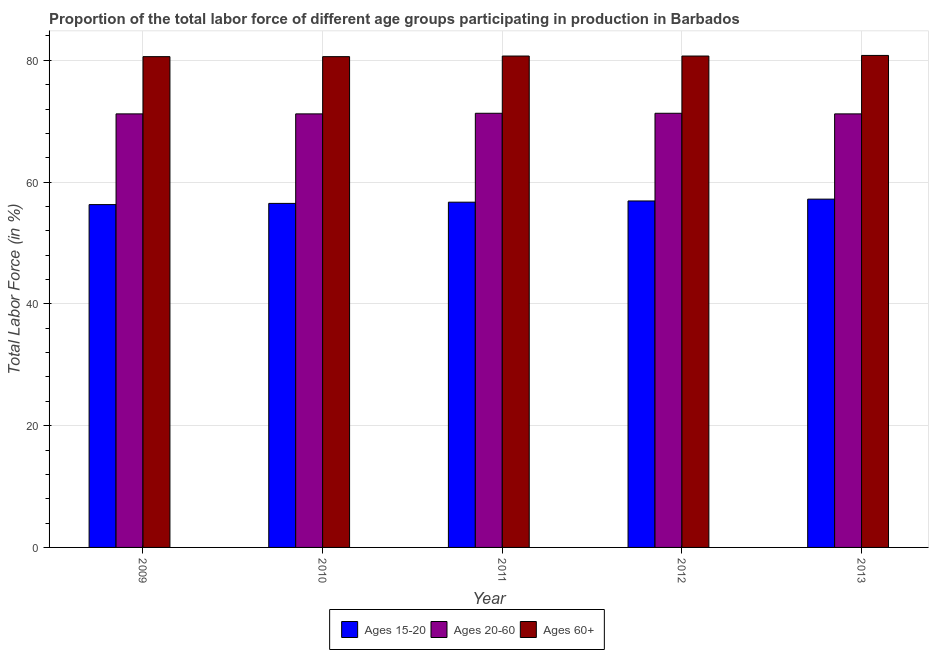How many bars are there on the 5th tick from the left?
Your answer should be compact. 3. How many bars are there on the 5th tick from the right?
Keep it short and to the point. 3. What is the label of the 4th group of bars from the left?
Offer a terse response. 2012. What is the percentage of labor force within the age group 20-60 in 2011?
Make the answer very short. 71.3. Across all years, what is the maximum percentage of labor force within the age group 15-20?
Provide a succinct answer. 57.2. Across all years, what is the minimum percentage of labor force within the age group 15-20?
Make the answer very short. 56.3. In which year was the percentage of labor force above age 60 maximum?
Provide a succinct answer. 2013. What is the total percentage of labor force within the age group 15-20 in the graph?
Give a very brief answer. 283.6. What is the difference between the percentage of labor force within the age group 20-60 in 2010 and that in 2011?
Make the answer very short. -0.1. What is the difference between the percentage of labor force within the age group 20-60 in 2013 and the percentage of labor force within the age group 15-20 in 2012?
Give a very brief answer. -0.1. What is the average percentage of labor force within the age group 15-20 per year?
Your answer should be very brief. 56.72. In the year 2009, what is the difference between the percentage of labor force within the age group 15-20 and percentage of labor force within the age group 20-60?
Ensure brevity in your answer.  0. In how many years, is the percentage of labor force within the age group 15-20 greater than 76 %?
Keep it short and to the point. 0. What is the ratio of the percentage of labor force within the age group 15-20 in 2009 to that in 2013?
Provide a succinct answer. 0.98. Is the percentage of labor force within the age group 20-60 in 2009 less than that in 2010?
Provide a short and direct response. No. Is the difference between the percentage of labor force above age 60 in 2009 and 2012 greater than the difference between the percentage of labor force within the age group 15-20 in 2009 and 2012?
Your response must be concise. No. What is the difference between the highest and the second highest percentage of labor force above age 60?
Make the answer very short. 0.1. What is the difference between the highest and the lowest percentage of labor force within the age group 20-60?
Offer a terse response. 0.1. What does the 2nd bar from the left in 2013 represents?
Ensure brevity in your answer.  Ages 20-60. What does the 2nd bar from the right in 2011 represents?
Your answer should be compact. Ages 20-60. Is it the case that in every year, the sum of the percentage of labor force within the age group 15-20 and percentage of labor force within the age group 20-60 is greater than the percentage of labor force above age 60?
Provide a short and direct response. Yes. Are all the bars in the graph horizontal?
Offer a very short reply. No. How many years are there in the graph?
Provide a short and direct response. 5. Does the graph contain any zero values?
Make the answer very short. No. Does the graph contain grids?
Your answer should be compact. Yes. How many legend labels are there?
Ensure brevity in your answer.  3. What is the title of the graph?
Your answer should be compact. Proportion of the total labor force of different age groups participating in production in Barbados. What is the label or title of the Y-axis?
Provide a short and direct response. Total Labor Force (in %). What is the Total Labor Force (in %) in Ages 15-20 in 2009?
Your answer should be very brief. 56.3. What is the Total Labor Force (in %) of Ages 20-60 in 2009?
Your answer should be very brief. 71.2. What is the Total Labor Force (in %) of Ages 60+ in 2009?
Your response must be concise. 80.6. What is the Total Labor Force (in %) in Ages 15-20 in 2010?
Offer a terse response. 56.5. What is the Total Labor Force (in %) in Ages 20-60 in 2010?
Your answer should be very brief. 71.2. What is the Total Labor Force (in %) in Ages 60+ in 2010?
Your answer should be very brief. 80.6. What is the Total Labor Force (in %) of Ages 15-20 in 2011?
Keep it short and to the point. 56.7. What is the Total Labor Force (in %) in Ages 20-60 in 2011?
Your answer should be compact. 71.3. What is the Total Labor Force (in %) of Ages 60+ in 2011?
Your answer should be very brief. 80.7. What is the Total Labor Force (in %) of Ages 15-20 in 2012?
Give a very brief answer. 56.9. What is the Total Labor Force (in %) of Ages 20-60 in 2012?
Your answer should be very brief. 71.3. What is the Total Labor Force (in %) in Ages 60+ in 2012?
Your response must be concise. 80.7. What is the Total Labor Force (in %) of Ages 15-20 in 2013?
Make the answer very short. 57.2. What is the Total Labor Force (in %) in Ages 20-60 in 2013?
Give a very brief answer. 71.2. What is the Total Labor Force (in %) of Ages 60+ in 2013?
Provide a succinct answer. 80.8. Across all years, what is the maximum Total Labor Force (in %) of Ages 15-20?
Your answer should be compact. 57.2. Across all years, what is the maximum Total Labor Force (in %) in Ages 20-60?
Your response must be concise. 71.3. Across all years, what is the maximum Total Labor Force (in %) of Ages 60+?
Your answer should be compact. 80.8. Across all years, what is the minimum Total Labor Force (in %) in Ages 15-20?
Offer a very short reply. 56.3. Across all years, what is the minimum Total Labor Force (in %) in Ages 20-60?
Offer a very short reply. 71.2. Across all years, what is the minimum Total Labor Force (in %) in Ages 60+?
Offer a very short reply. 80.6. What is the total Total Labor Force (in %) of Ages 15-20 in the graph?
Provide a short and direct response. 283.6. What is the total Total Labor Force (in %) of Ages 20-60 in the graph?
Your answer should be compact. 356.2. What is the total Total Labor Force (in %) of Ages 60+ in the graph?
Ensure brevity in your answer.  403.4. What is the difference between the Total Labor Force (in %) of Ages 15-20 in 2009 and that in 2010?
Offer a terse response. -0.2. What is the difference between the Total Labor Force (in %) in Ages 15-20 in 2009 and that in 2011?
Provide a succinct answer. -0.4. What is the difference between the Total Labor Force (in %) in Ages 20-60 in 2009 and that in 2011?
Offer a terse response. -0.1. What is the difference between the Total Labor Force (in %) of Ages 60+ in 2009 and that in 2011?
Give a very brief answer. -0.1. What is the difference between the Total Labor Force (in %) of Ages 15-20 in 2009 and that in 2012?
Give a very brief answer. -0.6. What is the difference between the Total Labor Force (in %) in Ages 20-60 in 2009 and that in 2012?
Give a very brief answer. -0.1. What is the difference between the Total Labor Force (in %) in Ages 60+ in 2009 and that in 2012?
Offer a terse response. -0.1. What is the difference between the Total Labor Force (in %) of Ages 15-20 in 2009 and that in 2013?
Provide a succinct answer. -0.9. What is the difference between the Total Labor Force (in %) of Ages 60+ in 2009 and that in 2013?
Provide a succinct answer. -0.2. What is the difference between the Total Labor Force (in %) of Ages 20-60 in 2010 and that in 2011?
Your answer should be very brief. -0.1. What is the difference between the Total Labor Force (in %) in Ages 20-60 in 2010 and that in 2012?
Offer a very short reply. -0.1. What is the difference between the Total Labor Force (in %) in Ages 60+ in 2010 and that in 2012?
Keep it short and to the point. -0.1. What is the difference between the Total Labor Force (in %) of Ages 15-20 in 2010 and that in 2013?
Offer a very short reply. -0.7. What is the difference between the Total Labor Force (in %) of Ages 60+ in 2010 and that in 2013?
Offer a very short reply. -0.2. What is the difference between the Total Labor Force (in %) in Ages 20-60 in 2011 and that in 2012?
Your answer should be very brief. 0. What is the difference between the Total Labor Force (in %) in Ages 60+ in 2011 and that in 2013?
Provide a short and direct response. -0.1. What is the difference between the Total Labor Force (in %) in Ages 20-60 in 2012 and that in 2013?
Provide a succinct answer. 0.1. What is the difference between the Total Labor Force (in %) of Ages 15-20 in 2009 and the Total Labor Force (in %) of Ages 20-60 in 2010?
Give a very brief answer. -14.9. What is the difference between the Total Labor Force (in %) in Ages 15-20 in 2009 and the Total Labor Force (in %) in Ages 60+ in 2010?
Offer a terse response. -24.3. What is the difference between the Total Labor Force (in %) in Ages 20-60 in 2009 and the Total Labor Force (in %) in Ages 60+ in 2010?
Your answer should be very brief. -9.4. What is the difference between the Total Labor Force (in %) in Ages 15-20 in 2009 and the Total Labor Force (in %) in Ages 20-60 in 2011?
Give a very brief answer. -15. What is the difference between the Total Labor Force (in %) in Ages 15-20 in 2009 and the Total Labor Force (in %) in Ages 60+ in 2011?
Ensure brevity in your answer.  -24.4. What is the difference between the Total Labor Force (in %) in Ages 20-60 in 2009 and the Total Labor Force (in %) in Ages 60+ in 2011?
Your answer should be compact. -9.5. What is the difference between the Total Labor Force (in %) in Ages 15-20 in 2009 and the Total Labor Force (in %) in Ages 20-60 in 2012?
Your answer should be very brief. -15. What is the difference between the Total Labor Force (in %) in Ages 15-20 in 2009 and the Total Labor Force (in %) in Ages 60+ in 2012?
Give a very brief answer. -24.4. What is the difference between the Total Labor Force (in %) of Ages 20-60 in 2009 and the Total Labor Force (in %) of Ages 60+ in 2012?
Ensure brevity in your answer.  -9.5. What is the difference between the Total Labor Force (in %) of Ages 15-20 in 2009 and the Total Labor Force (in %) of Ages 20-60 in 2013?
Your answer should be very brief. -14.9. What is the difference between the Total Labor Force (in %) in Ages 15-20 in 2009 and the Total Labor Force (in %) in Ages 60+ in 2013?
Provide a succinct answer. -24.5. What is the difference between the Total Labor Force (in %) in Ages 20-60 in 2009 and the Total Labor Force (in %) in Ages 60+ in 2013?
Make the answer very short. -9.6. What is the difference between the Total Labor Force (in %) in Ages 15-20 in 2010 and the Total Labor Force (in %) in Ages 20-60 in 2011?
Offer a terse response. -14.8. What is the difference between the Total Labor Force (in %) of Ages 15-20 in 2010 and the Total Labor Force (in %) of Ages 60+ in 2011?
Keep it short and to the point. -24.2. What is the difference between the Total Labor Force (in %) of Ages 15-20 in 2010 and the Total Labor Force (in %) of Ages 20-60 in 2012?
Make the answer very short. -14.8. What is the difference between the Total Labor Force (in %) of Ages 15-20 in 2010 and the Total Labor Force (in %) of Ages 60+ in 2012?
Provide a succinct answer. -24.2. What is the difference between the Total Labor Force (in %) of Ages 15-20 in 2010 and the Total Labor Force (in %) of Ages 20-60 in 2013?
Offer a terse response. -14.7. What is the difference between the Total Labor Force (in %) in Ages 15-20 in 2010 and the Total Labor Force (in %) in Ages 60+ in 2013?
Provide a succinct answer. -24.3. What is the difference between the Total Labor Force (in %) of Ages 20-60 in 2010 and the Total Labor Force (in %) of Ages 60+ in 2013?
Provide a succinct answer. -9.6. What is the difference between the Total Labor Force (in %) in Ages 15-20 in 2011 and the Total Labor Force (in %) in Ages 20-60 in 2012?
Offer a terse response. -14.6. What is the difference between the Total Labor Force (in %) of Ages 15-20 in 2011 and the Total Labor Force (in %) of Ages 60+ in 2012?
Provide a succinct answer. -24. What is the difference between the Total Labor Force (in %) in Ages 20-60 in 2011 and the Total Labor Force (in %) in Ages 60+ in 2012?
Keep it short and to the point. -9.4. What is the difference between the Total Labor Force (in %) in Ages 15-20 in 2011 and the Total Labor Force (in %) in Ages 60+ in 2013?
Give a very brief answer. -24.1. What is the difference between the Total Labor Force (in %) in Ages 15-20 in 2012 and the Total Labor Force (in %) in Ages 20-60 in 2013?
Your response must be concise. -14.3. What is the difference between the Total Labor Force (in %) of Ages 15-20 in 2012 and the Total Labor Force (in %) of Ages 60+ in 2013?
Offer a very short reply. -23.9. What is the average Total Labor Force (in %) of Ages 15-20 per year?
Offer a terse response. 56.72. What is the average Total Labor Force (in %) of Ages 20-60 per year?
Keep it short and to the point. 71.24. What is the average Total Labor Force (in %) of Ages 60+ per year?
Ensure brevity in your answer.  80.68. In the year 2009, what is the difference between the Total Labor Force (in %) of Ages 15-20 and Total Labor Force (in %) of Ages 20-60?
Provide a succinct answer. -14.9. In the year 2009, what is the difference between the Total Labor Force (in %) of Ages 15-20 and Total Labor Force (in %) of Ages 60+?
Your answer should be very brief. -24.3. In the year 2010, what is the difference between the Total Labor Force (in %) of Ages 15-20 and Total Labor Force (in %) of Ages 20-60?
Your answer should be very brief. -14.7. In the year 2010, what is the difference between the Total Labor Force (in %) of Ages 15-20 and Total Labor Force (in %) of Ages 60+?
Make the answer very short. -24.1. In the year 2010, what is the difference between the Total Labor Force (in %) in Ages 20-60 and Total Labor Force (in %) in Ages 60+?
Keep it short and to the point. -9.4. In the year 2011, what is the difference between the Total Labor Force (in %) of Ages 15-20 and Total Labor Force (in %) of Ages 20-60?
Give a very brief answer. -14.6. In the year 2011, what is the difference between the Total Labor Force (in %) in Ages 15-20 and Total Labor Force (in %) in Ages 60+?
Your answer should be very brief. -24. In the year 2011, what is the difference between the Total Labor Force (in %) in Ages 20-60 and Total Labor Force (in %) in Ages 60+?
Offer a terse response. -9.4. In the year 2012, what is the difference between the Total Labor Force (in %) in Ages 15-20 and Total Labor Force (in %) in Ages 20-60?
Ensure brevity in your answer.  -14.4. In the year 2012, what is the difference between the Total Labor Force (in %) of Ages 15-20 and Total Labor Force (in %) of Ages 60+?
Ensure brevity in your answer.  -23.8. In the year 2012, what is the difference between the Total Labor Force (in %) in Ages 20-60 and Total Labor Force (in %) in Ages 60+?
Your response must be concise. -9.4. In the year 2013, what is the difference between the Total Labor Force (in %) in Ages 15-20 and Total Labor Force (in %) in Ages 60+?
Your answer should be very brief. -23.6. What is the ratio of the Total Labor Force (in %) of Ages 20-60 in 2009 to that in 2010?
Ensure brevity in your answer.  1. What is the ratio of the Total Labor Force (in %) in Ages 15-20 in 2009 to that in 2011?
Ensure brevity in your answer.  0.99. What is the ratio of the Total Labor Force (in %) in Ages 60+ in 2009 to that in 2011?
Offer a terse response. 1. What is the ratio of the Total Labor Force (in %) of Ages 60+ in 2009 to that in 2012?
Your answer should be very brief. 1. What is the ratio of the Total Labor Force (in %) in Ages 15-20 in 2009 to that in 2013?
Offer a very short reply. 0.98. What is the ratio of the Total Labor Force (in %) of Ages 60+ in 2009 to that in 2013?
Your answer should be very brief. 1. What is the ratio of the Total Labor Force (in %) in Ages 15-20 in 2010 to that in 2011?
Make the answer very short. 1. What is the ratio of the Total Labor Force (in %) in Ages 20-60 in 2010 to that in 2011?
Your response must be concise. 1. What is the ratio of the Total Labor Force (in %) in Ages 60+ in 2010 to that in 2011?
Make the answer very short. 1. What is the ratio of the Total Labor Force (in %) in Ages 60+ in 2010 to that in 2012?
Your answer should be very brief. 1. What is the ratio of the Total Labor Force (in %) of Ages 15-20 in 2010 to that in 2013?
Give a very brief answer. 0.99. What is the ratio of the Total Labor Force (in %) in Ages 20-60 in 2010 to that in 2013?
Keep it short and to the point. 1. What is the ratio of the Total Labor Force (in %) of Ages 20-60 in 2011 to that in 2013?
Make the answer very short. 1. What is the ratio of the Total Labor Force (in %) in Ages 60+ in 2011 to that in 2013?
Your answer should be very brief. 1. What is the difference between the highest and the second highest Total Labor Force (in %) of Ages 20-60?
Offer a terse response. 0. What is the difference between the highest and the lowest Total Labor Force (in %) of Ages 20-60?
Give a very brief answer. 0.1. What is the difference between the highest and the lowest Total Labor Force (in %) in Ages 60+?
Your answer should be compact. 0.2. 